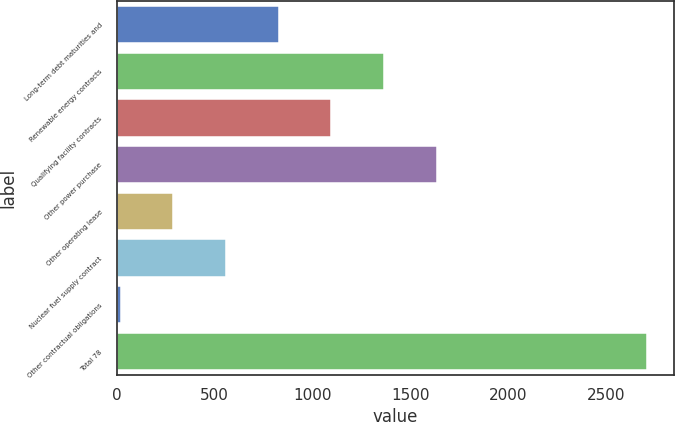Convert chart to OTSL. <chart><loc_0><loc_0><loc_500><loc_500><bar_chart><fcel>Long-term debt maturities and<fcel>Renewable energy contracts<fcel>Qualifying facility contracts<fcel>Other power purchase<fcel>Other operating lease<fcel>Nuclear fuel supply contract<fcel>Other contractual obligations<fcel>Total 78<nl><fcel>827.4<fcel>1365<fcel>1096.2<fcel>1633.8<fcel>289.8<fcel>558.6<fcel>21<fcel>2709<nl></chart> 